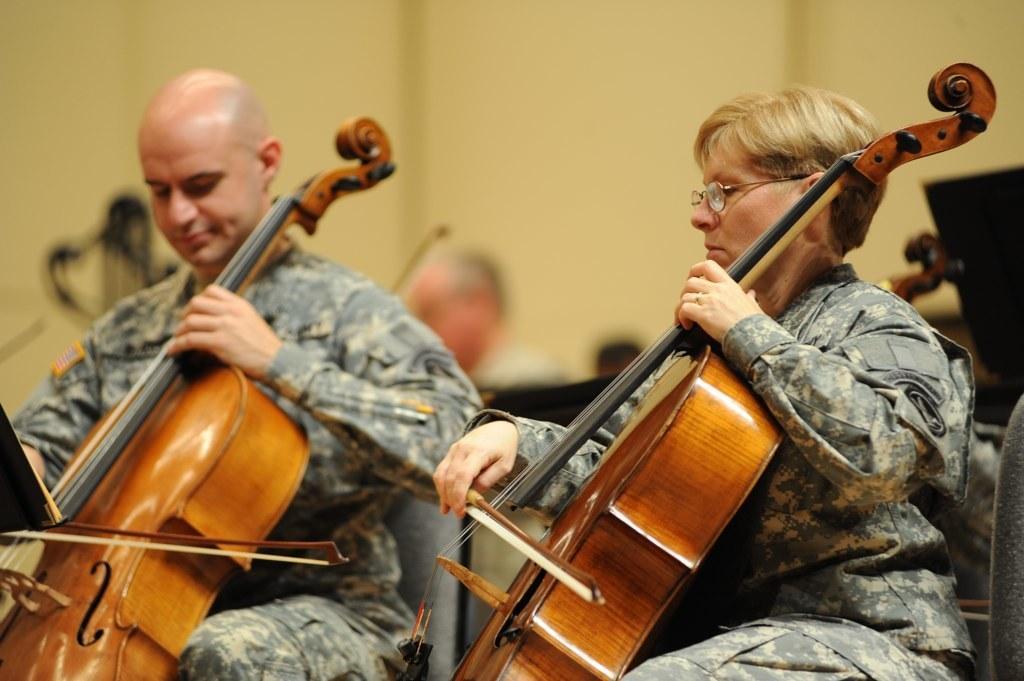Could you give a brief overview of what you see in this image? Here a man is sitting and playing violin next to him there is a woman playing the violin. In the background we see a wall and a person sitting behind these two people. 